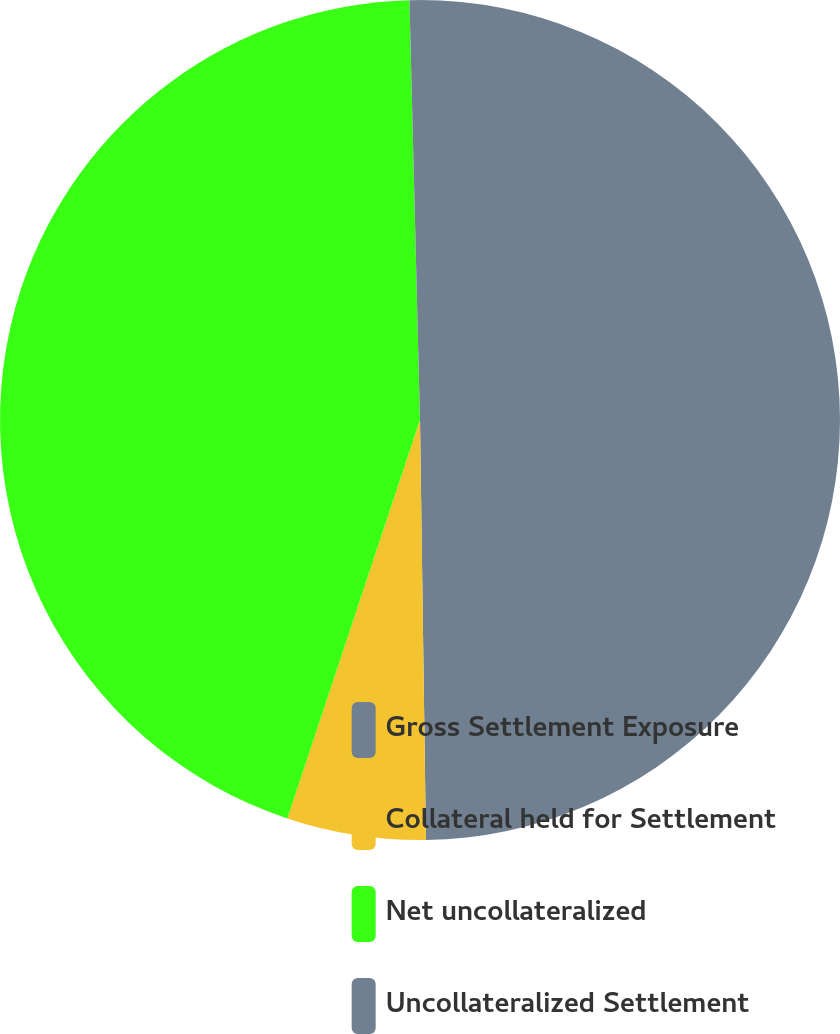<chart> <loc_0><loc_0><loc_500><loc_500><pie_chart><fcel>Gross Settlement Exposure<fcel>Collateral held for Settlement<fcel>Net uncollateralized<fcel>Uncollateralized Settlement<nl><fcel>49.77%<fcel>5.34%<fcel>44.48%<fcel>0.4%<nl></chart> 